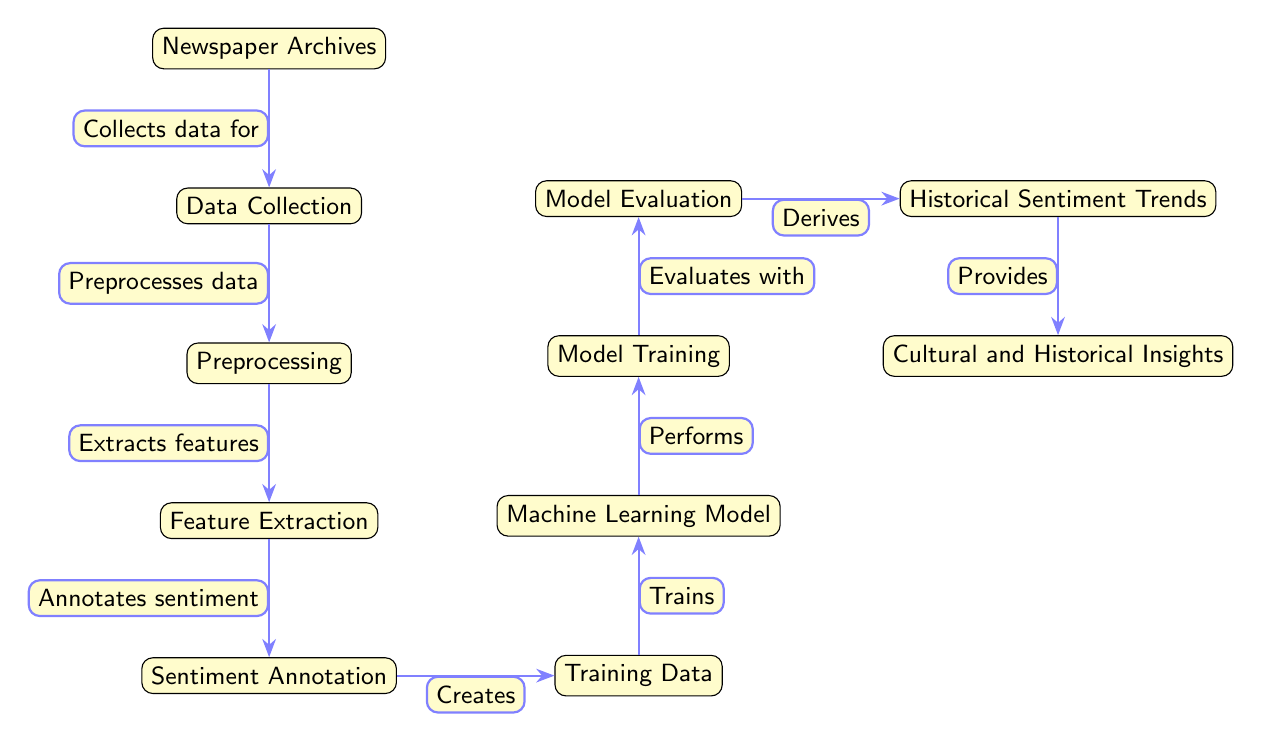What is the first node in the diagram? The first node in the diagram is labeled "Newspaper Archives," which represents the starting point of the process.
Answer: Newspaper Archives How many nodes are present in the diagram? By counting each labeled node from top to bottom, we find a total of eleven nodes in the diagram.
Answer: 11 What is the function of the fourth node? The fourth node is labeled "Feature Extraction," indicating its role in the process where specific characteristics are identified from the preprocessed data.
Answer: Extracts features What connects the Sentiment Annotation node to the Training Data node? The connection is established through the phrase "Creates," indicating that the sentiment annotations result in the formation of training data for the model.
Answer: Creates What is derived after the Model Evaluation node? After the Model Evaluation node, the next step outputs "Historical Sentiment Trends," representing the results of the model's evaluation relating to sentiments over time.
Answer: Historical Sentiment Trends What is the relationship between the Machine Learning Model and Model Training nodes? The Machine Learning Model node is linked to the Model Training node with the phrase "Trains," suggesting that the model undergoes training as the next step in the process.
Answer: Trains Which node provides insights as the final output? The last node in the process is labeled "Cultural and Historical Insights," indicating that this is the final output gained from analyzing the sentiment trends derived earlier.
Answer: Cultural and Historical Insights What type of analysis does this diagram illustrate? The diagram illustrates a sentiment analysis of newspaper articles, focusing on extracting and understanding emotional content over different eras using machine learning techniques.
Answer: Sentiment analysis Which step comes immediately before the Model Evaluation step? Immediately preceding the Model Evaluation step is the "Model Training" step, highlighting the sequence of operations that lead to the evaluation process.
Answer: Model Training What is the main goal represented by the last node? The main goal represented by the last node is to provide insights into cultural and historical contexts from the sentiment analysis conducted on the newspaper data.
Answer: Provides 